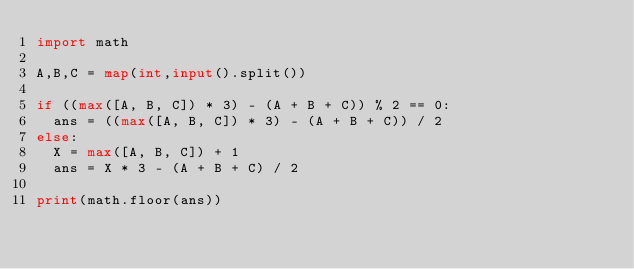<code> <loc_0><loc_0><loc_500><loc_500><_Python_>import math

A,B,C = map(int,input().split())

if ((max([A, B, C]) * 3) - (A + B + C)) % 2 == 0:
  ans = ((max([A, B, C]) * 3) - (A + B + C)) / 2
else:
  X = max([A, B, C]) + 1
  ans = X * 3 - (A + B + C) / 2

print(math.floor(ans))</code> 